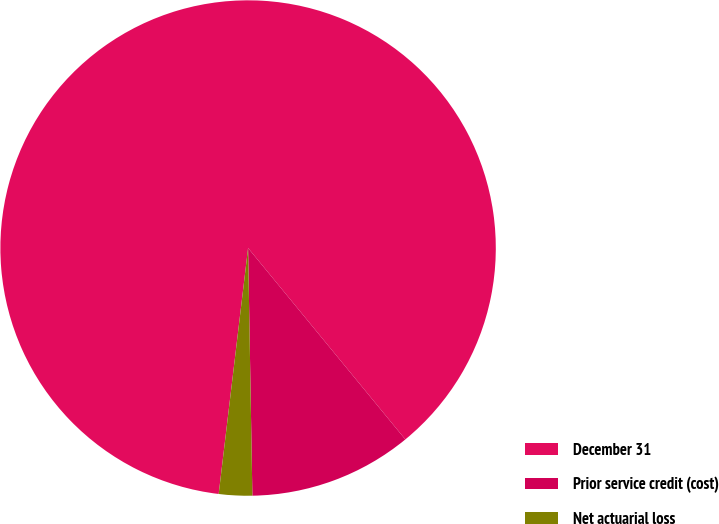Convert chart to OTSL. <chart><loc_0><loc_0><loc_500><loc_500><pie_chart><fcel>December 31<fcel>Prior service credit (cost)<fcel>Net actuarial loss<nl><fcel>87.16%<fcel>10.67%<fcel>2.17%<nl></chart> 